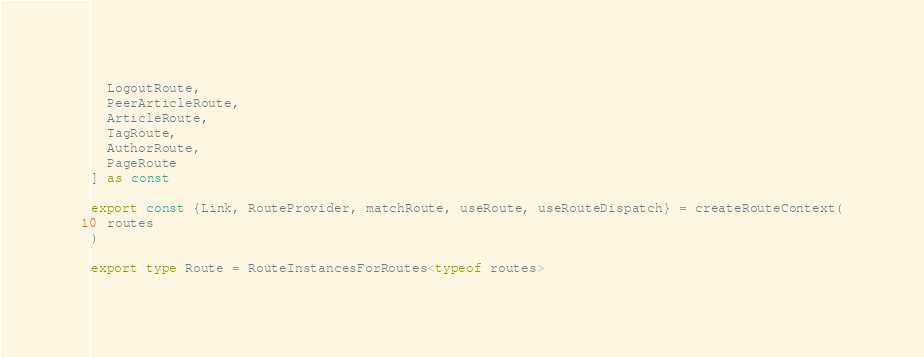<code> <loc_0><loc_0><loc_500><loc_500><_TypeScript_>  LogoutRoute,
  PeerArticleRoute,
  ArticleRoute,
  TagRoute,
  AuthorRoute,
  PageRoute
] as const

export const {Link, RouteProvider, matchRoute, useRoute, useRouteDispatch} = createRouteContext(
  routes
)

export type Route = RouteInstancesForRoutes<typeof routes>
</code> 